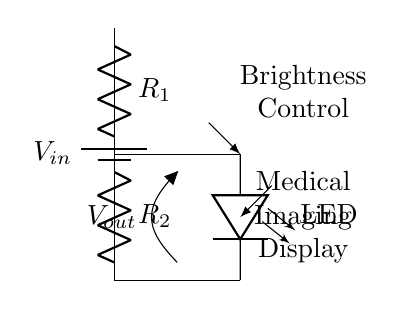What type of component is R1? R1 is a resistor, which is typically used to limit current in a circuit. The diagram clearly labels R1 as a resistor.
Answer: Resistor What is the purpose of the voltage divider circuit in this context? The voltage divider is used to adjust the output voltage, which controls the brightness of the LED displays. The configuration allows voltage division based on the resistor values.
Answer: Brightness control What is the relationship between R1 and R2 in this circuit? R1 and R2 are connected in series, forming a voltage divider that allows the voltage across R2 to be controlled, affecting the LED brightness.
Answer: Series What is the function of the LED in this circuit? The LED acts as an indicator or display component, illuminated based on the output voltage from the voltage divider. When a specific voltage is applied, it lights up.
Answer: Indicator How can changing the values of R1 and R2 affect the output voltage? Adjusting R1 and R2 alters the resistance in the circuit, which changes the voltage drop across R2. According to the voltage divider formula, this affects the output voltage.
Answer: Changes output voltage What happens if R2 is a very small value? If R2 is very small, the output voltage will drop significantly, potentially leading to lower brightness of the LED since most voltage will drop across R1.
Answer: Lower brightness What is the voltage output across R2 if R1 is twice the value of R2? The output voltage across R2 will be one-third of the input voltage, as it follows the voltage divider principle. The division is directly influenced by the resistor values.
Answer: One-third of Vin 